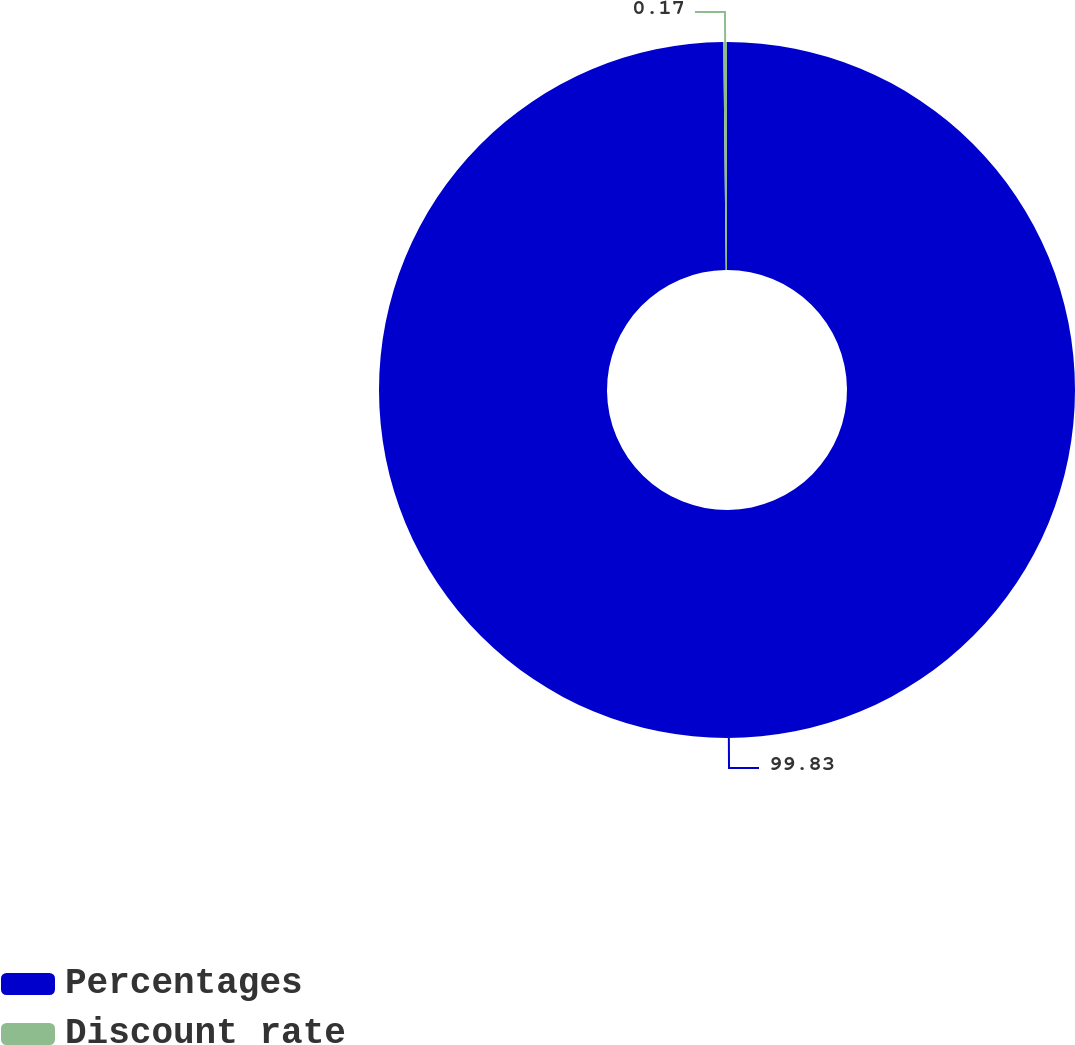Convert chart to OTSL. <chart><loc_0><loc_0><loc_500><loc_500><pie_chart><fcel>Percentages<fcel>Discount rate<nl><fcel>99.83%<fcel>0.17%<nl></chart> 